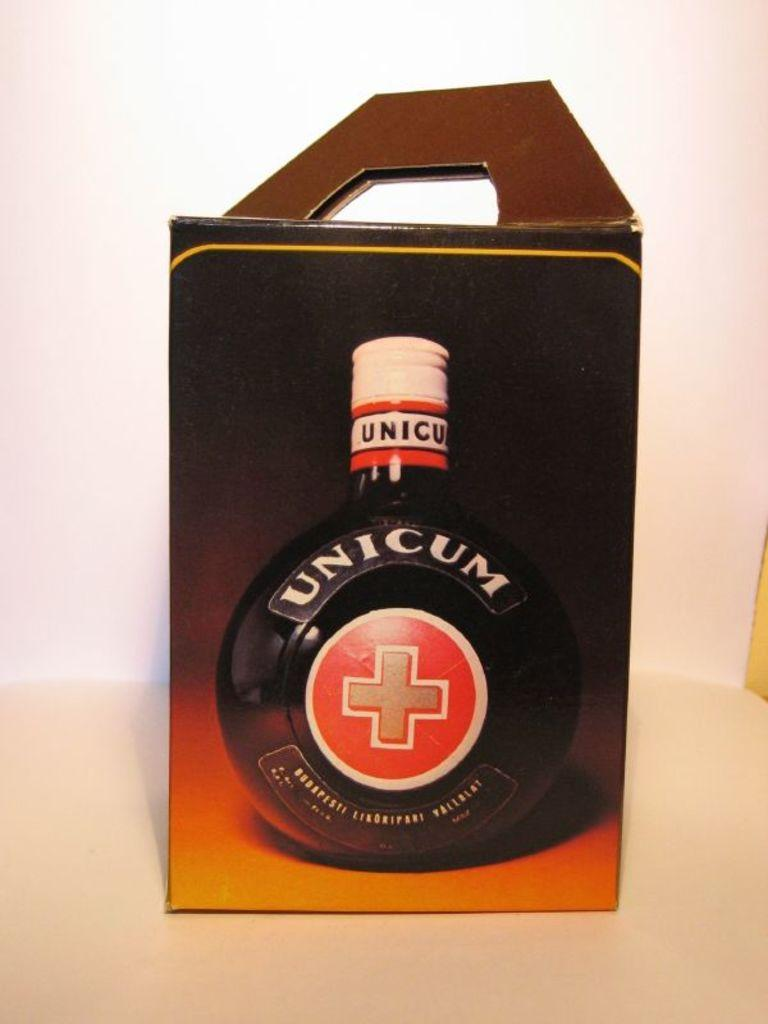<image>
Describe the image concisely. a box with a plastic handle that says 'unicum' on it 